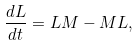<formula> <loc_0><loc_0><loc_500><loc_500>\frac { d L } { d t } = L M - M L ,</formula> 